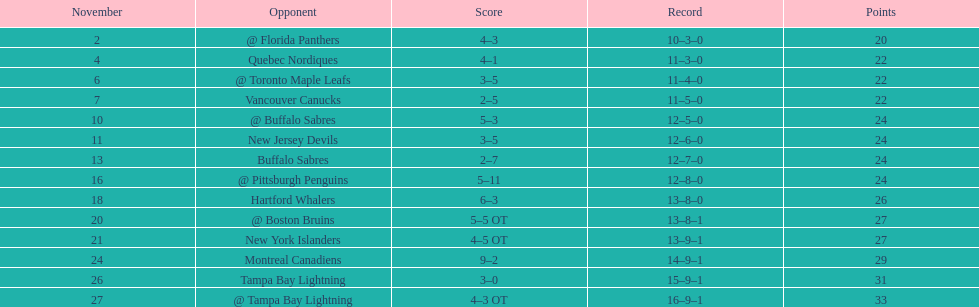Which was the only team in the atlantic division in the 1993-1994 season to acquire less points than the philadelphia flyers? Tampa Bay Lightning. 